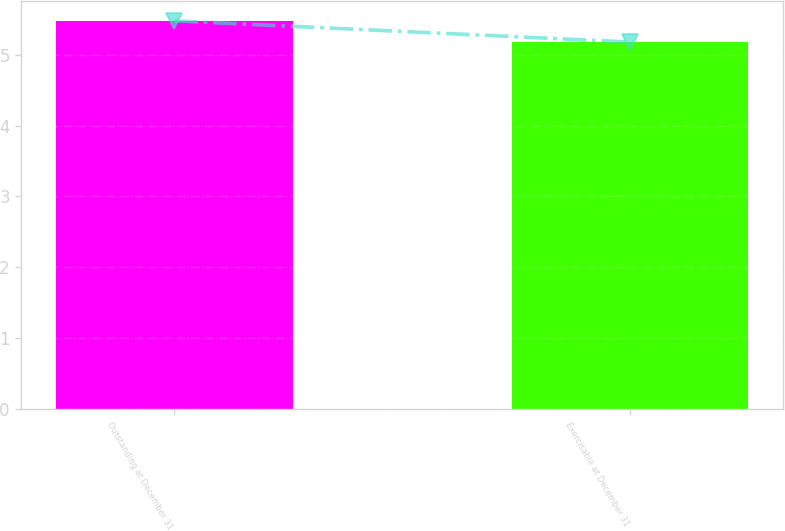Convert chart. <chart><loc_0><loc_0><loc_500><loc_500><bar_chart><fcel>Outstanding at December 31<fcel>Exercisable at December 31<nl><fcel>5.48<fcel>5.18<nl></chart> 